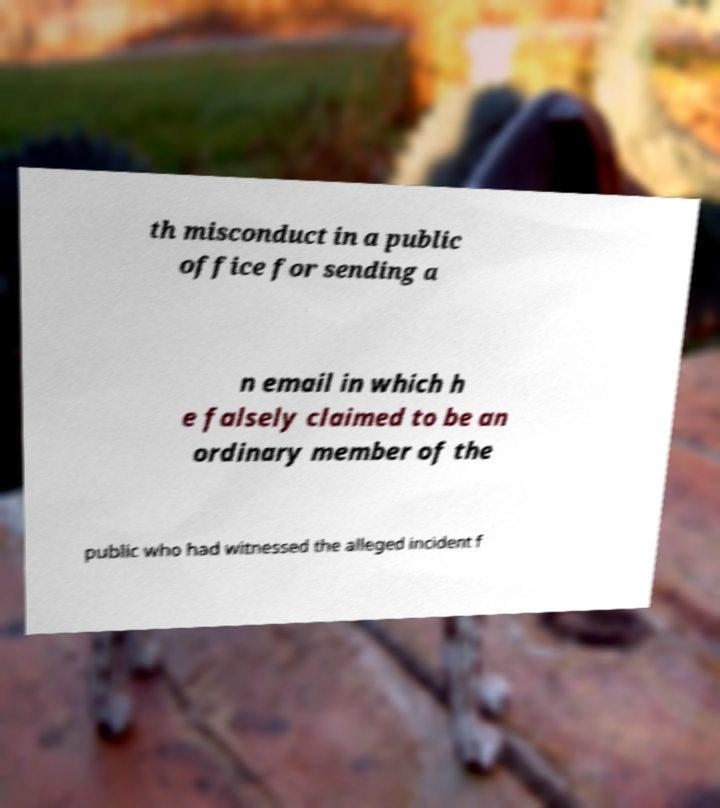Can you accurately transcribe the text from the provided image for me? th misconduct in a public office for sending a n email in which h e falsely claimed to be an ordinary member of the public who had witnessed the alleged incident f 